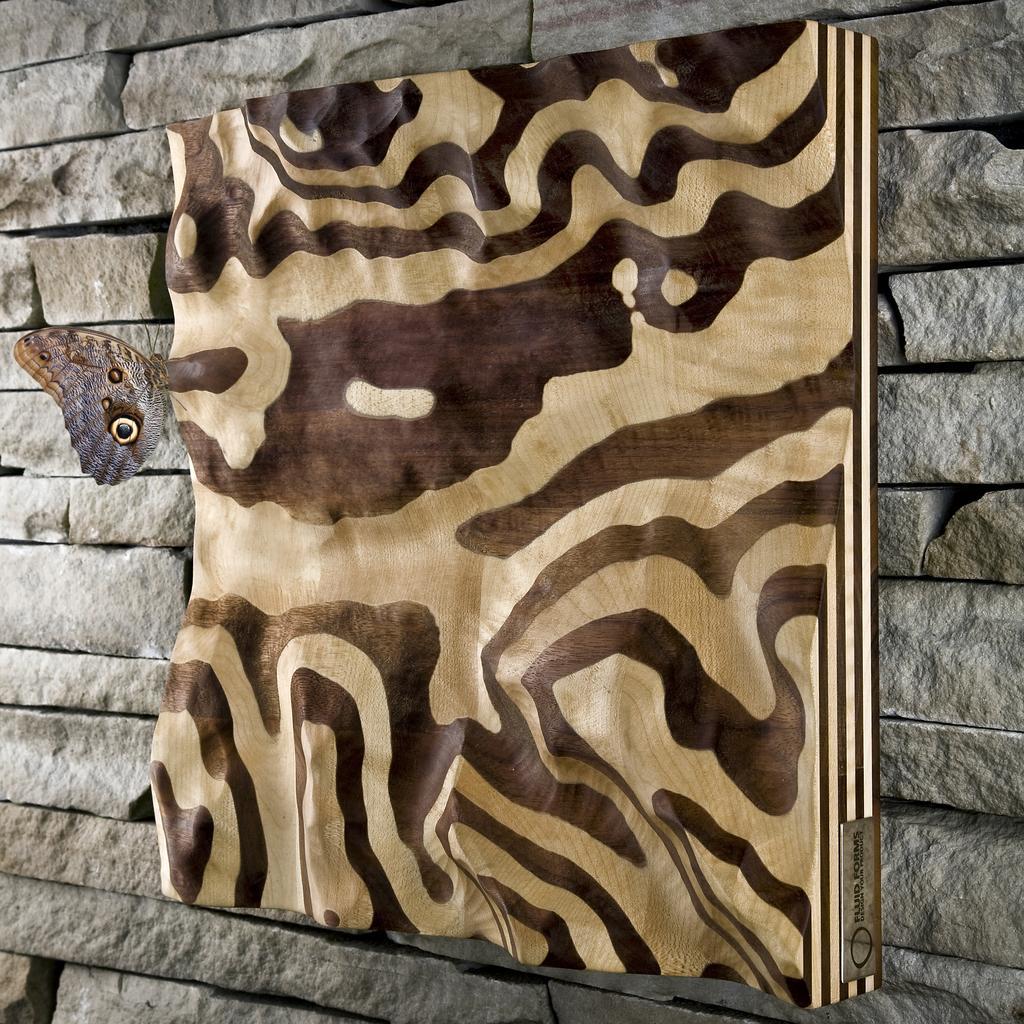Can you describe this image briefly? In the picture I can see the frame on the stone wall and there is a butterfly on the left side. 